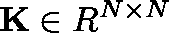Convert formula to latex. <formula><loc_0><loc_0><loc_500><loc_500>{ K } \in { \boldmath R } ^ { N \times N }</formula> 